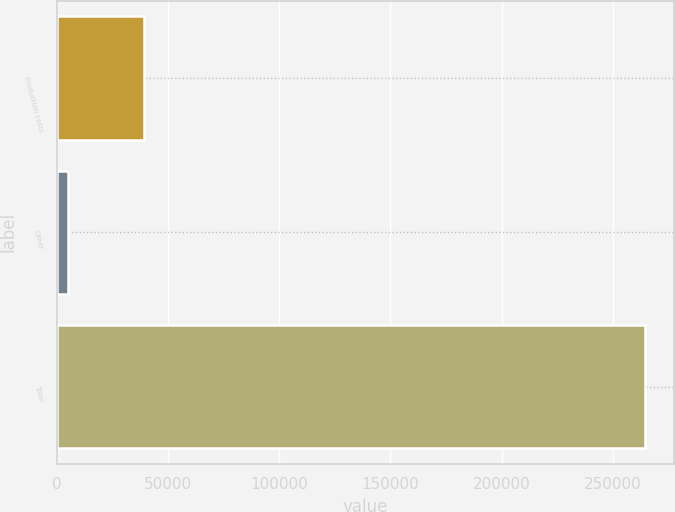Convert chart. <chart><loc_0><loc_0><loc_500><loc_500><bar_chart><fcel>Production costs<fcel>Other<fcel>Total<nl><fcel>38943<fcel>4738<fcel>264253<nl></chart> 